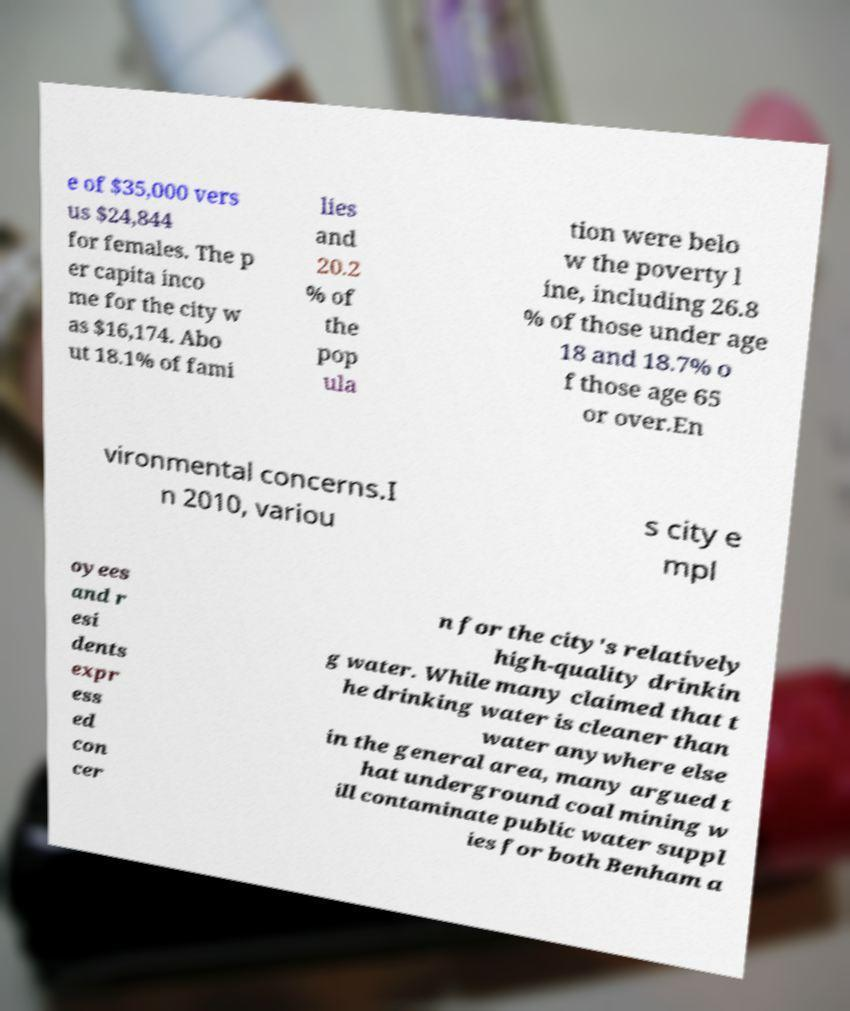I need the written content from this picture converted into text. Can you do that? e of $35,000 vers us $24,844 for females. The p er capita inco me for the city w as $16,174. Abo ut 18.1% of fami lies and 20.2 % of the pop ula tion were belo w the poverty l ine, including 26.8 % of those under age 18 and 18.7% o f those age 65 or over.En vironmental concerns.I n 2010, variou s city e mpl oyees and r esi dents expr ess ed con cer n for the city's relatively high-quality drinkin g water. While many claimed that t he drinking water is cleaner than water anywhere else in the general area, many argued t hat underground coal mining w ill contaminate public water suppl ies for both Benham a 